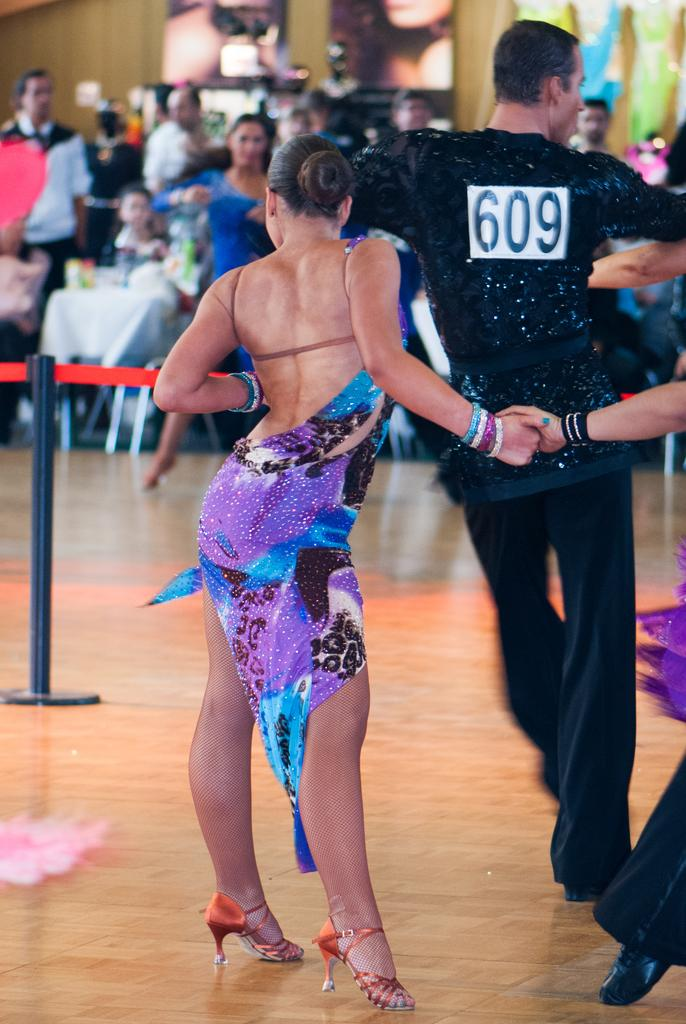Who is present in the image? There is a woman in the image. What is the woman doing in the image? The woman is holding the hand of a person. Can you describe the position of the other person in relation to the woman? There is another person in front of the woman. Are there any other people visible in the image? Yes, there are a few other people in the background of the image. What type of railway is visible in the image? There is no railway present in the image. How many hands are visible in the image? It is not possible to determine the exact number of hands visible in the image, as only one hand is mentioned to be held by the woman. 